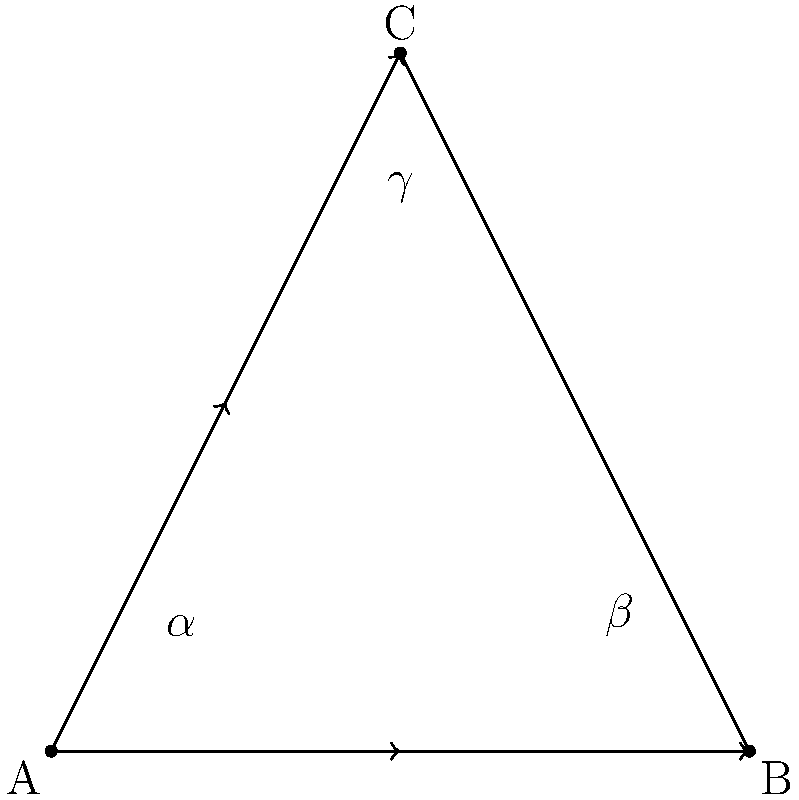In this hieroglyphic carving depicting a triangular shape, three angles $\alpha$, $\beta$, and $\gamma$ are formed. If $\alpha = 45°$ and $\beta = 60°$, what is the measure of angle $\gamma$? Explain the significance of this angle in relation to ancient Egyptian mathematical and spiritual beliefs. To solve this problem and understand its significance, let's follow these steps:

1. Recall the Triangle Angle Sum Theorem: The sum of the measures of the three angles in a triangle is always 180°.

2. We are given:
   $\alpha = 45°$
   $\beta = 60°$

3. Let's use the theorem to find $\gamma$:
   $\alpha + \beta + \gamma = 180°$
   $45° + 60° + \gamma = 180°$
   $105° + \gamma = 180°$
   $\gamma = 180° - 105° = 75°$

4. Significance in ancient Egyptian beliefs:
   a) The number 75 can be factored as 3 × 25, which may have been significant as 3 was associated with the trinity of major gods (Osiris, Isis, and Horus), and 25 represented the number of Egyptian nomes (administrative divisions).
   
   b) In Egyptian mathematics, they used a base-10 number system. The angle 75° is exactly 5/24 of a full circle (360°). This fraction might have been significant in their astronomical calculations or calendar systems.
   
   c) The Egyptians were skilled in geometry, particularly for architectural purposes. An angle of 75° could have been used in the design of pyramids or temples, possibly relating to alignments with celestial bodies.
   
   d) In spiritual symbolism, triangles often represented the connection between the physical and spiritual realms. The specific angles might have been chosen to reflect certain cosmic principles or divine proportions.

5. The use of precise angles in hieroglyphic carvings demonstrates the ancient Egyptians' advanced understanding of geometry and its application in both practical and spiritual contexts.
Answer: $75°$; represents divine proportions and astronomical alignments 